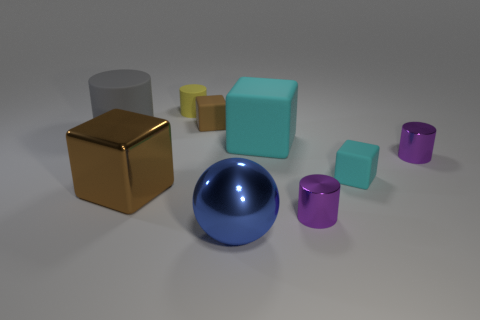Add 1 tiny brown rubber things. How many objects exist? 10 Subtract all cubes. How many objects are left? 5 Add 7 tiny metal cylinders. How many tiny metal cylinders exist? 9 Subtract 1 blue spheres. How many objects are left? 8 Subtract all blue shiny spheres. Subtract all large cylinders. How many objects are left? 7 Add 6 big shiny objects. How many big shiny objects are left? 8 